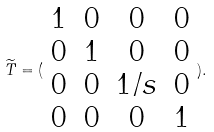<formula> <loc_0><loc_0><loc_500><loc_500>\widetilde { T } = ( \begin{array} { c c c c } 1 & 0 & 0 & 0 \\ 0 & 1 & 0 & 0 \\ 0 & 0 & 1 / s & 0 \\ 0 & 0 & 0 & 1 \end{array} ) .</formula> 